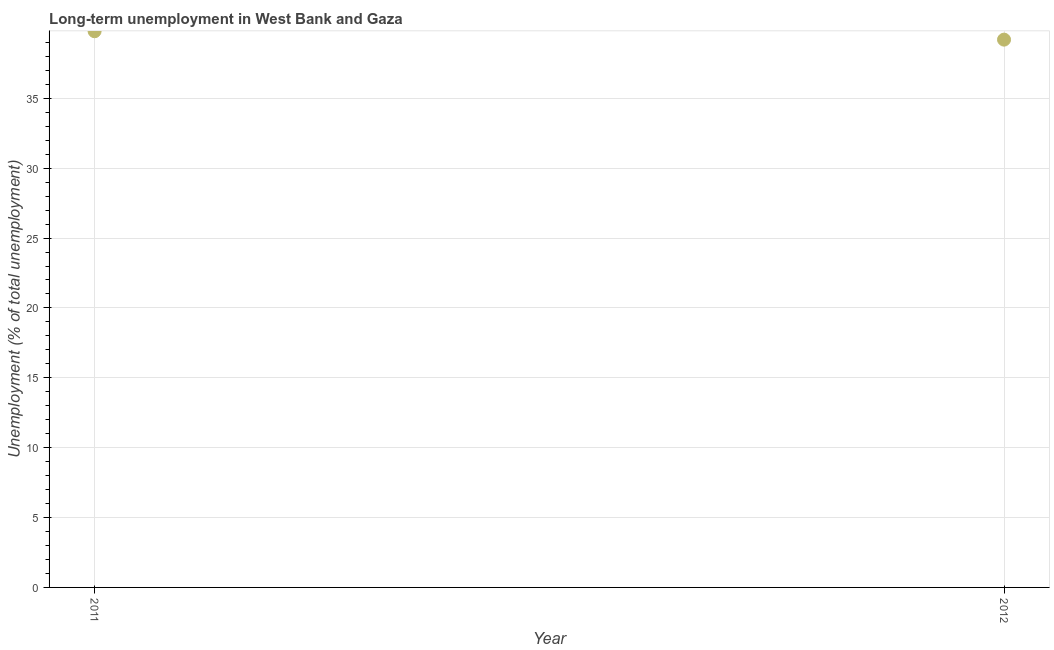What is the long-term unemployment in 2011?
Ensure brevity in your answer.  39.8. Across all years, what is the maximum long-term unemployment?
Offer a terse response. 39.8. Across all years, what is the minimum long-term unemployment?
Make the answer very short. 39.2. In which year was the long-term unemployment minimum?
Ensure brevity in your answer.  2012. What is the sum of the long-term unemployment?
Offer a very short reply. 79. What is the difference between the long-term unemployment in 2011 and 2012?
Keep it short and to the point. 0.6. What is the average long-term unemployment per year?
Provide a short and direct response. 39.5. What is the median long-term unemployment?
Your answer should be very brief. 39.5. In how many years, is the long-term unemployment greater than 4 %?
Provide a succinct answer. 2. What is the ratio of the long-term unemployment in 2011 to that in 2012?
Give a very brief answer. 1.02. In how many years, is the long-term unemployment greater than the average long-term unemployment taken over all years?
Provide a short and direct response. 1. What is the difference between two consecutive major ticks on the Y-axis?
Offer a terse response. 5. Are the values on the major ticks of Y-axis written in scientific E-notation?
Offer a terse response. No. Does the graph contain grids?
Your response must be concise. Yes. What is the title of the graph?
Offer a very short reply. Long-term unemployment in West Bank and Gaza. What is the label or title of the X-axis?
Offer a very short reply. Year. What is the label or title of the Y-axis?
Your answer should be compact. Unemployment (% of total unemployment). What is the Unemployment (% of total unemployment) in 2011?
Give a very brief answer. 39.8. What is the Unemployment (% of total unemployment) in 2012?
Keep it short and to the point. 39.2. What is the ratio of the Unemployment (% of total unemployment) in 2011 to that in 2012?
Ensure brevity in your answer.  1.01. 